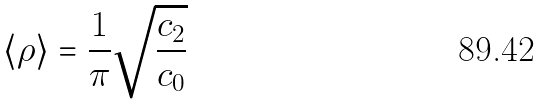<formula> <loc_0><loc_0><loc_500><loc_500>\left \langle \rho \right \rangle = \frac { 1 } { \pi } \sqrt { \frac { c _ { 2 } } { c _ { 0 } } }</formula> 